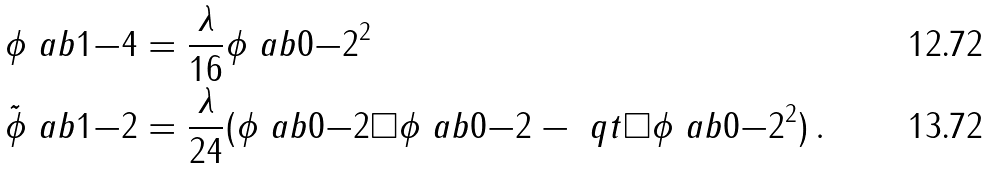Convert formula to latex. <formula><loc_0><loc_0><loc_500><loc_500>\phi \ a b { 1 } { - 4 } & = \frac { \lambda } { 1 6 } \phi \ a b { 0 } { - 2 } ^ { 2 } \\ \tilde { \phi } \ a b { 1 } { - 2 } & = \frac { \lambda } { 2 4 } ( \phi \ a b { 0 } { - 2 } \square \phi \ a b { 0 } { - 2 } - \ q t \square \phi \ a b { 0 } { - 2 } ^ { 2 } ) \, .</formula> 